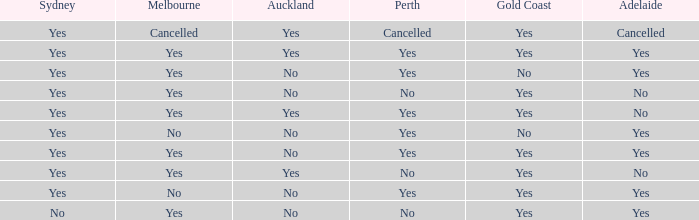What is the sydney that has adelaide, gold coast, melbourne, and auckland are all yes? Yes. 